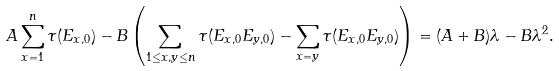Convert formula to latex. <formula><loc_0><loc_0><loc_500><loc_500>A \sum _ { x = 1 } ^ { n } \tau ( E _ { x , 0 } ) - B \left ( \sum _ { 1 \leq x , y \leq n } \tau ( E _ { x , 0 } E _ { y , 0 } ) - \sum _ { x = y } \tau ( E _ { x , 0 } E _ { y , 0 } ) \right ) = ( A + B ) \lambda - B \lambda ^ { 2 } .</formula> 